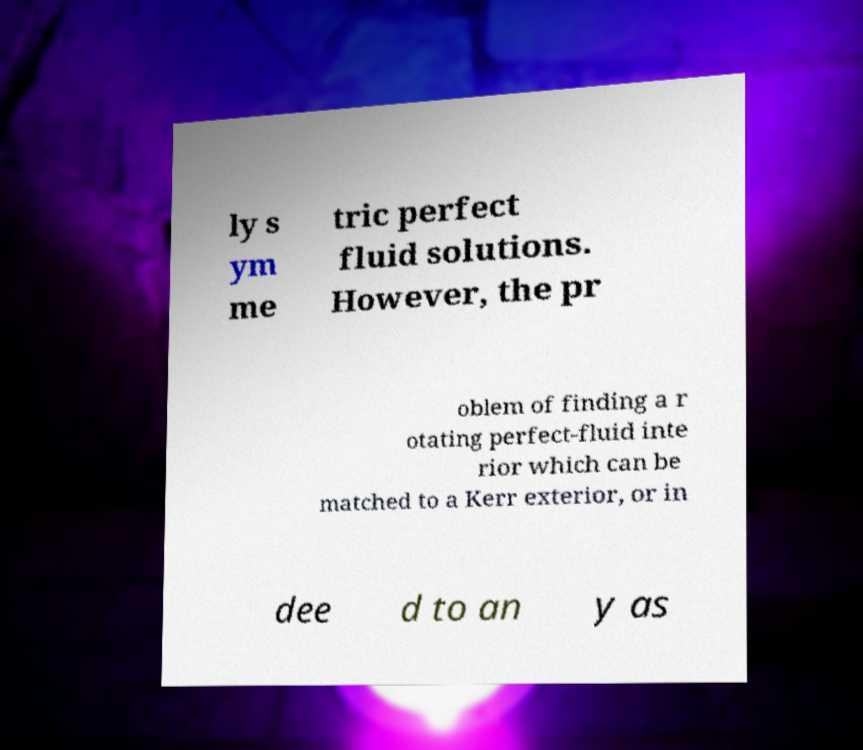What messages or text are displayed in this image? I need them in a readable, typed format. ly s ym me tric perfect fluid solutions. However, the pr oblem of finding a r otating perfect-fluid inte rior which can be matched to a Kerr exterior, or in dee d to an y as 